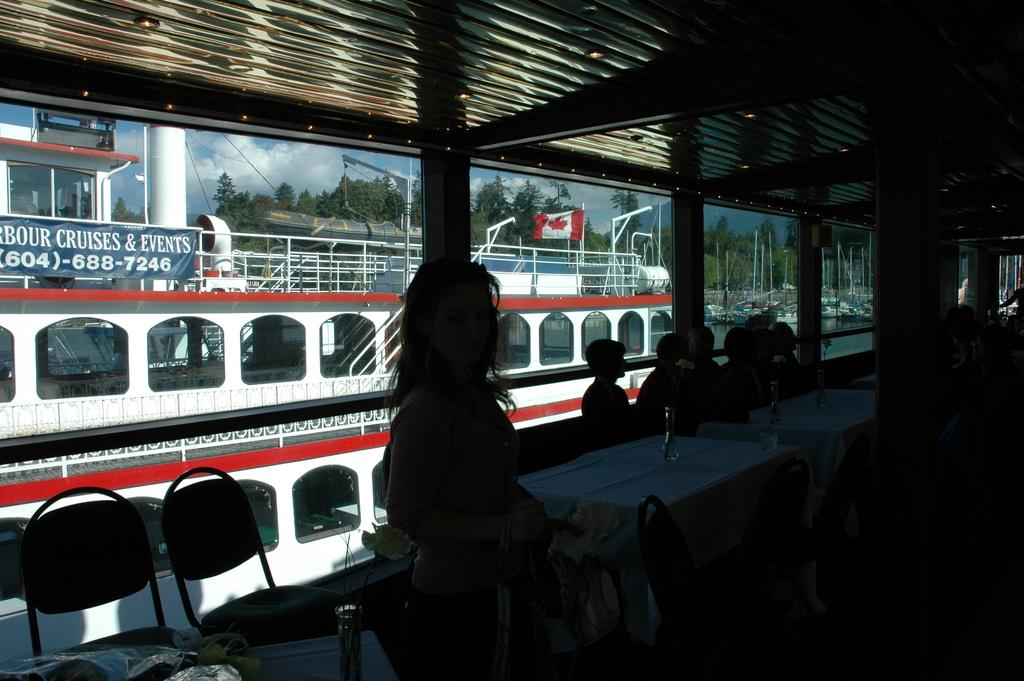What is the main subject of the image? The main subject of the image is ships. What is the setting of the image? The ships are on water, and there are chairs, tables, and people sitting on chairs in the image. What can be seen in the background of the image? There are trees, a flag, and a banner in the background of the image. How would you describe the sky in the image? The sky is a combination of white and blue colors. How much money is being exchanged between the people sitting on chairs in the image? There is no indication of money exchange in the image; people are simply sitting on chairs. What type of roof is visible in the image? There is no roof present in the image. 